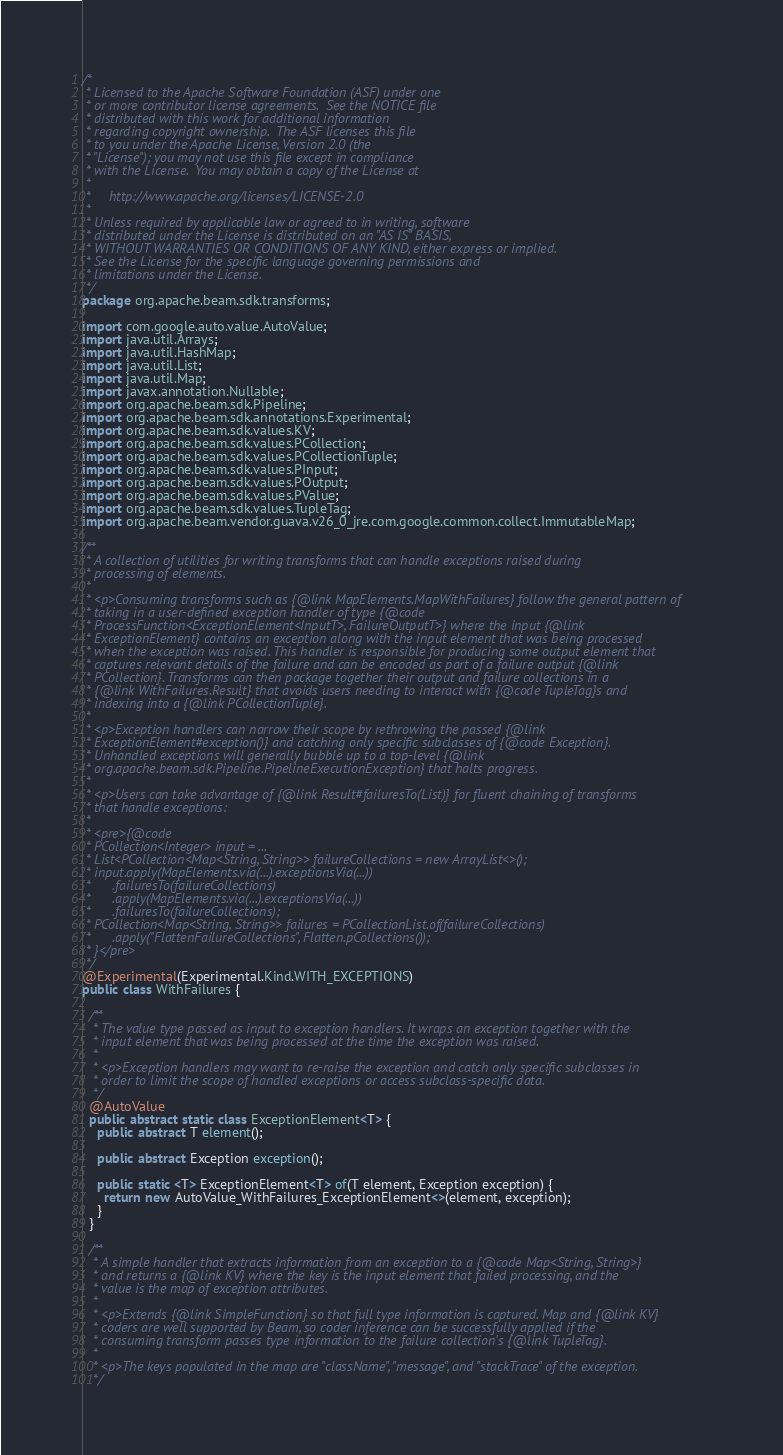<code> <loc_0><loc_0><loc_500><loc_500><_Java_>/*
 * Licensed to the Apache Software Foundation (ASF) under one
 * or more contributor license agreements.  See the NOTICE file
 * distributed with this work for additional information
 * regarding copyright ownership.  The ASF licenses this file
 * to you under the Apache License, Version 2.0 (the
 * "License"); you may not use this file except in compliance
 * with the License.  You may obtain a copy of the License at
 *
 *     http://www.apache.org/licenses/LICENSE-2.0
 *
 * Unless required by applicable law or agreed to in writing, software
 * distributed under the License is distributed on an "AS IS" BASIS,
 * WITHOUT WARRANTIES OR CONDITIONS OF ANY KIND, either express or implied.
 * See the License for the specific language governing permissions and
 * limitations under the License.
 */
package org.apache.beam.sdk.transforms;

import com.google.auto.value.AutoValue;
import java.util.Arrays;
import java.util.HashMap;
import java.util.List;
import java.util.Map;
import javax.annotation.Nullable;
import org.apache.beam.sdk.Pipeline;
import org.apache.beam.sdk.annotations.Experimental;
import org.apache.beam.sdk.values.KV;
import org.apache.beam.sdk.values.PCollection;
import org.apache.beam.sdk.values.PCollectionTuple;
import org.apache.beam.sdk.values.PInput;
import org.apache.beam.sdk.values.POutput;
import org.apache.beam.sdk.values.PValue;
import org.apache.beam.sdk.values.TupleTag;
import org.apache.beam.vendor.guava.v26_0_jre.com.google.common.collect.ImmutableMap;

/**
 * A collection of utilities for writing transforms that can handle exceptions raised during
 * processing of elements.
 *
 * <p>Consuming transforms such as {@link MapElements.MapWithFailures} follow the general pattern of
 * taking in a user-defined exception handler of type {@code
 * ProcessFunction<ExceptionElement<InputT>, FailureOutputT>} where the input {@link
 * ExceptionElement} contains an exception along with the input element that was being processed
 * when the exception was raised. This handler is responsible for producing some output element that
 * captures relevant details of the failure and can be encoded as part of a failure output {@link
 * PCollection}. Transforms can then package together their output and failure collections in a
 * {@link WithFailures.Result} that avoids users needing to interact with {@code TupleTag}s and
 * indexing into a {@link PCollectionTuple}.
 *
 * <p>Exception handlers can narrow their scope by rethrowing the passed {@link
 * ExceptionElement#exception()} and catching only specific subclasses of {@code Exception}.
 * Unhandled exceptions will generally bubble up to a top-level {@link
 * org.apache.beam.sdk.Pipeline.PipelineExecutionException} that halts progress.
 *
 * <p>Users can take advantage of {@link Result#failuresTo(List)} for fluent chaining of transforms
 * that handle exceptions:
 *
 * <pre>{@code
 * PCollection<Integer> input = ...
 * List<PCollection<Map<String, String>> failureCollections = new ArrayList<>();
 * input.apply(MapElements.via(...).exceptionsVia(...))
 *      .failuresTo(failureCollections)
 *      .apply(MapElements.via(...).exceptionsVia(...))
 *      .failuresTo(failureCollections);
 * PCollection<Map<String, String>> failures = PCollectionList.of(failureCollections)
 *      .apply("FlattenFailureCollections", Flatten.pCollections());
 * }</pre>
 */
@Experimental(Experimental.Kind.WITH_EXCEPTIONS)
public class WithFailures {

  /**
   * The value type passed as input to exception handlers. It wraps an exception together with the
   * input element that was being processed at the time the exception was raised.
   *
   * <p>Exception handlers may want to re-raise the exception and catch only specific subclasses in
   * order to limit the scope of handled exceptions or access subclass-specific data.
   */
  @AutoValue
  public abstract static class ExceptionElement<T> {
    public abstract T element();

    public abstract Exception exception();

    public static <T> ExceptionElement<T> of(T element, Exception exception) {
      return new AutoValue_WithFailures_ExceptionElement<>(element, exception);
    }
  }

  /**
   * A simple handler that extracts information from an exception to a {@code Map<String, String>}
   * and returns a {@link KV} where the key is the input element that failed processing, and the
   * value is the map of exception attributes.
   *
   * <p>Extends {@link SimpleFunction} so that full type information is captured. Map and {@link KV}
   * coders are well supported by Beam, so coder inference can be successfully applied if the
   * consuming transform passes type information to the failure collection's {@link TupleTag}.
   *
   * <p>The keys populated in the map are "className", "message", and "stackTrace" of the exception.
   */</code> 